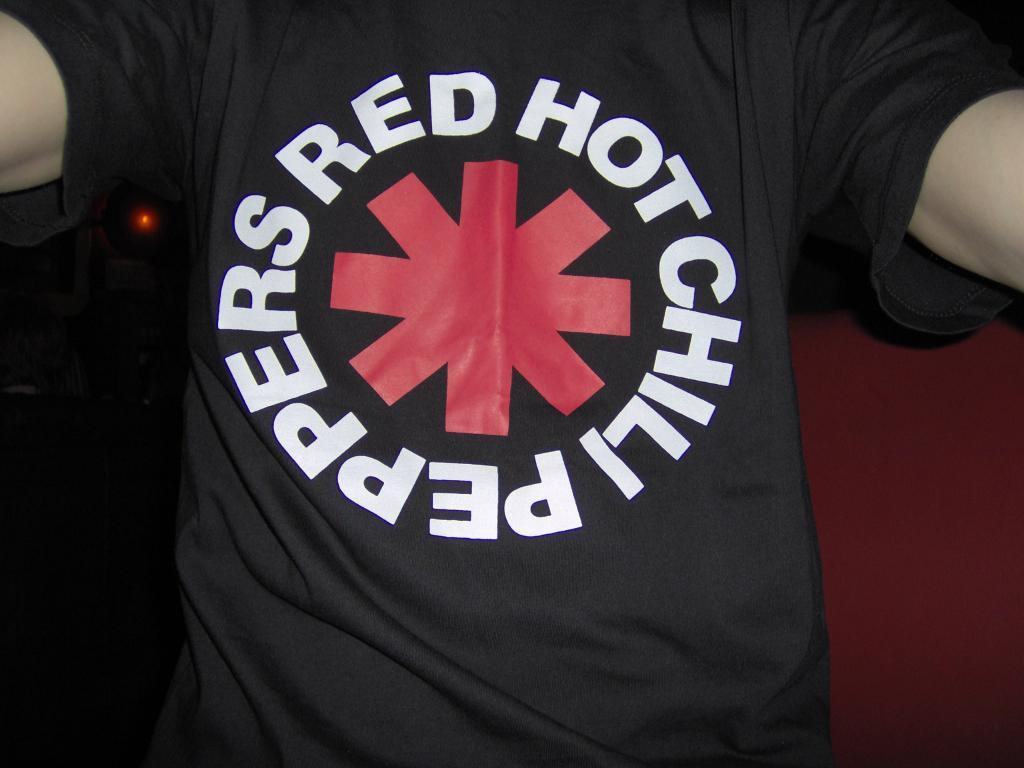<image>
Share a concise interpretation of the image provided. A person is wearing a shirt with a red symbol that says Red chilli peppers. 